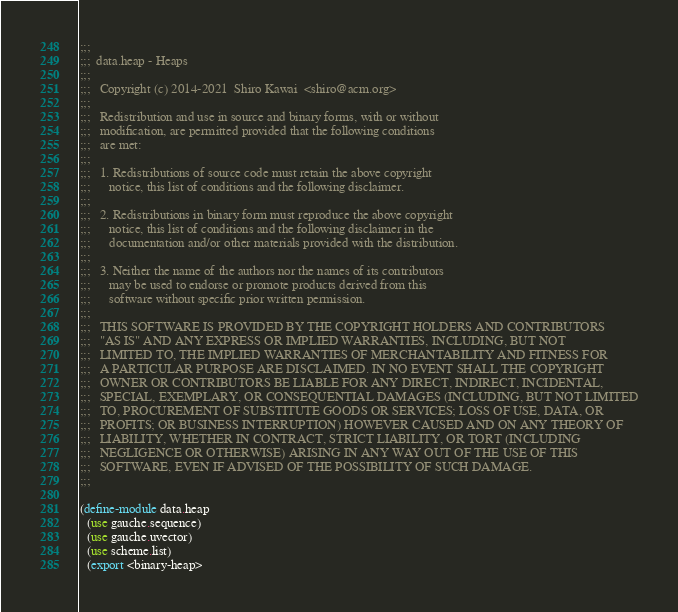<code> <loc_0><loc_0><loc_500><loc_500><_Scheme_>;;;
;;;  data.heap - Heaps
;;;
;;;   Copyright (c) 2014-2021  Shiro Kawai  <shiro@acm.org>
;;;
;;;   Redistribution and use in source and binary forms, with or without
;;;   modification, are permitted provided that the following conditions
;;;   are met:
;;;
;;;   1. Redistributions of source code must retain the above copyright
;;;      notice, this list of conditions and the following disclaimer.
;;;
;;;   2. Redistributions in binary form must reproduce the above copyright
;;;      notice, this list of conditions and the following disclaimer in the
;;;      documentation and/or other materials provided with the distribution.
;;;
;;;   3. Neither the name of the authors nor the names of its contributors
;;;      may be used to endorse or promote products derived from this
;;;      software without specific prior written permission.
;;;
;;;   THIS SOFTWARE IS PROVIDED BY THE COPYRIGHT HOLDERS AND CONTRIBUTORS
;;;   "AS IS" AND ANY EXPRESS OR IMPLIED WARRANTIES, INCLUDING, BUT NOT
;;;   LIMITED TO, THE IMPLIED WARRANTIES OF MERCHANTABILITY AND FITNESS FOR
;;;   A PARTICULAR PURPOSE ARE DISCLAIMED. IN NO EVENT SHALL THE COPYRIGHT
;;;   OWNER OR CONTRIBUTORS BE LIABLE FOR ANY DIRECT, INDIRECT, INCIDENTAL,
;;;   SPECIAL, EXEMPLARY, OR CONSEQUENTIAL DAMAGES (INCLUDING, BUT NOT LIMITED
;;;   TO, PROCUREMENT OF SUBSTITUTE GOODS OR SERVICES; LOSS OF USE, DATA, OR
;;;   PROFITS; OR BUSINESS INTERRUPTION) HOWEVER CAUSED AND ON ANY THEORY OF
;;;   LIABILITY, WHETHER IN CONTRACT, STRICT LIABILITY, OR TORT (INCLUDING
;;;   NEGLIGENCE OR OTHERWISE) ARISING IN ANY WAY OUT OF THE USE OF THIS
;;;   SOFTWARE, EVEN IF ADVISED OF THE POSSIBILITY OF SUCH DAMAGE.
;;;

(define-module data.heap
  (use gauche.sequence)
  (use gauche.uvector)
  (use scheme.list)
  (export <binary-heap></code> 